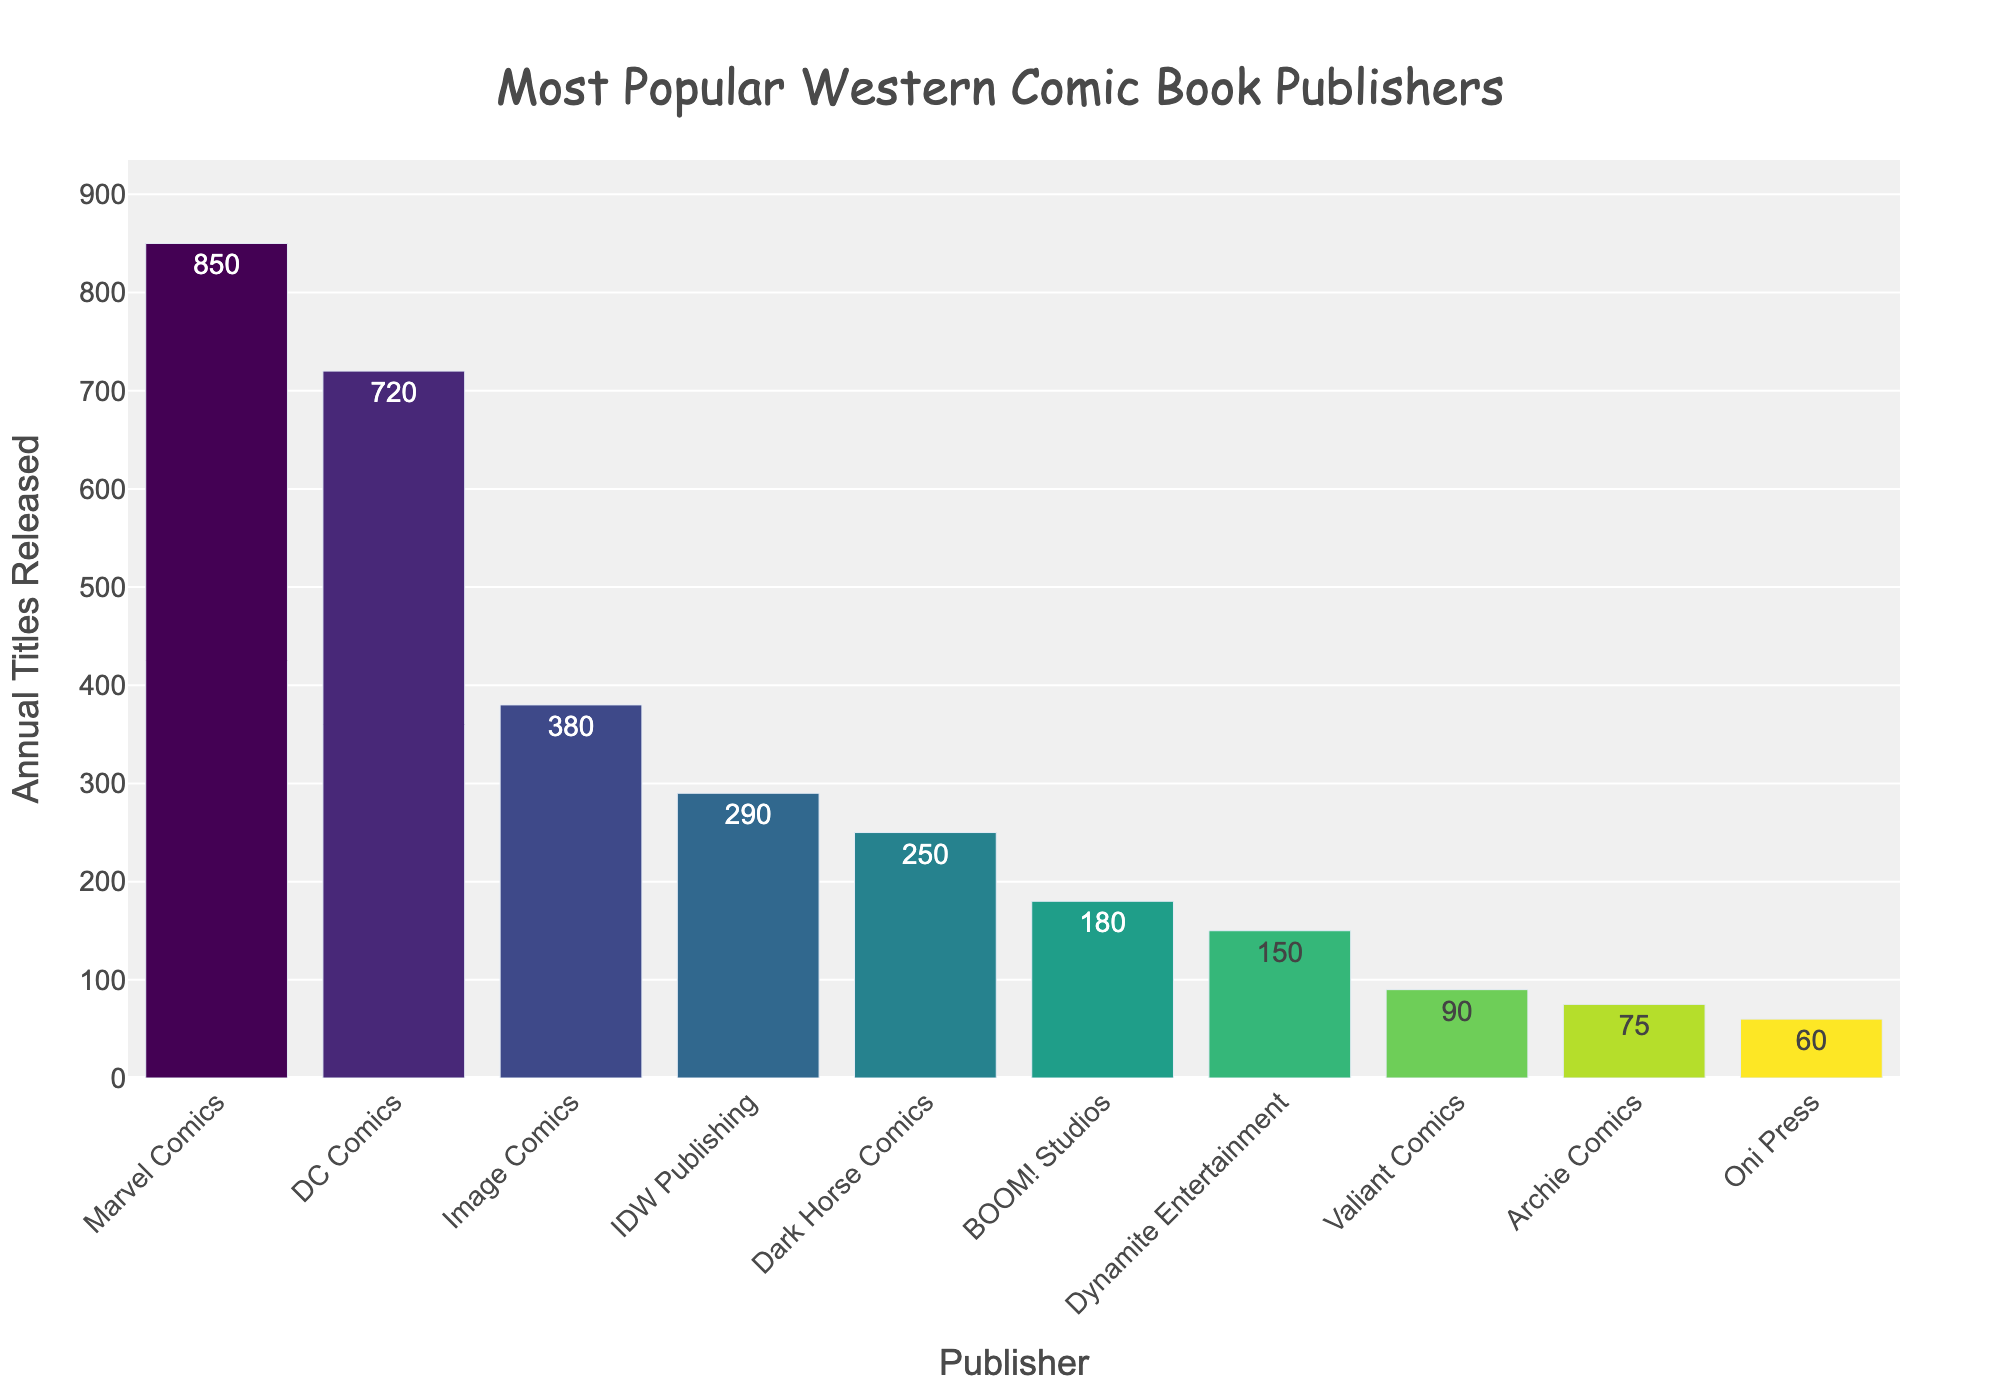What is the publisher with the highest number of annual titles released? By looking at the height of the bars, the tallest bar represents the publisher with the highest number of annual titles released. Here, the tallest bar belongs to Marvel Comics.
Answer: Marvel Comics Which publisher releases fewer annual titles: Dark Horse Comics or BOOM! Studios? By comparing the heights of the bars for Dark Horse Comics and BOOM! Studios, Dark Horse Comics has a taller bar, indicating it releases more titles annually compared to BOOM! Studios.
Answer: BOOM! Studios What is the combined number of annual titles released by Image Comics and IDW Publishing? Image Comics releases 380 titles and IDW Publishing releases 290 titles. Adding these together: 380 + 290 = 670.
Answer: 670 Which publishers release fewer than 100 annual titles? By looking at the bars with heights less than 100, the bars for Valiant Comics, Archie Comics, and Oni Press are below this mark.
Answer: Valiant Comics, Archie Comics, Oni Press What is the difference in the number of annual titles between DC Comics and Dark Horse Comics? DC Comics releases 720 titles annually while Dark Horse Comics releases 250 titles. The difference is 720 - 250 = 470.
Answer: 470 What is the average number of annual titles released by the top three publishers? The top three publishers are Marvel Comics (850), DC Comics (720), and Image Comics (380). The total number of titles released by these three publishers is 850 + 720 + 380 = 1950. Dividing by 3 gives the average: 1950 / 3 = 650.
Answer: 650 Which two publishers have the closest number of annual titles released, and what is their difference? By comparing the bars, BOOM! Studios (180) and Dynamite Entertainment (150) seem the closest. The difference is 180 - 150 = 30.
Answer: BOOM! Studios and Dynamite Entertainment, 30 What is the range of annual titles released among all publishers? The range is the difference between the highest and lowest values. The highest is Marvel Comics (850) and the lowest is Oni Press (60). The range is 850 - 60 = 790.
Answer: 790 Which publisher releases more titles annually: Dynamite Entertainment or Archie Comics? By comparing the heights of the bars for Dynamite Entertainment and Archie Comics, Dynamite Entertainment has a taller bar.
Answer: Dynamite Entertainment What's the median number of annual titles released among all publishers? To find the median, list the number of titles in ascending order: 60, 75, 90, 150, 180, 250, 290, 380, 720, 850. The middle two numbers are 180 and 250, so the median is (180 + 250) / 2 = 215.
Answer: 215 